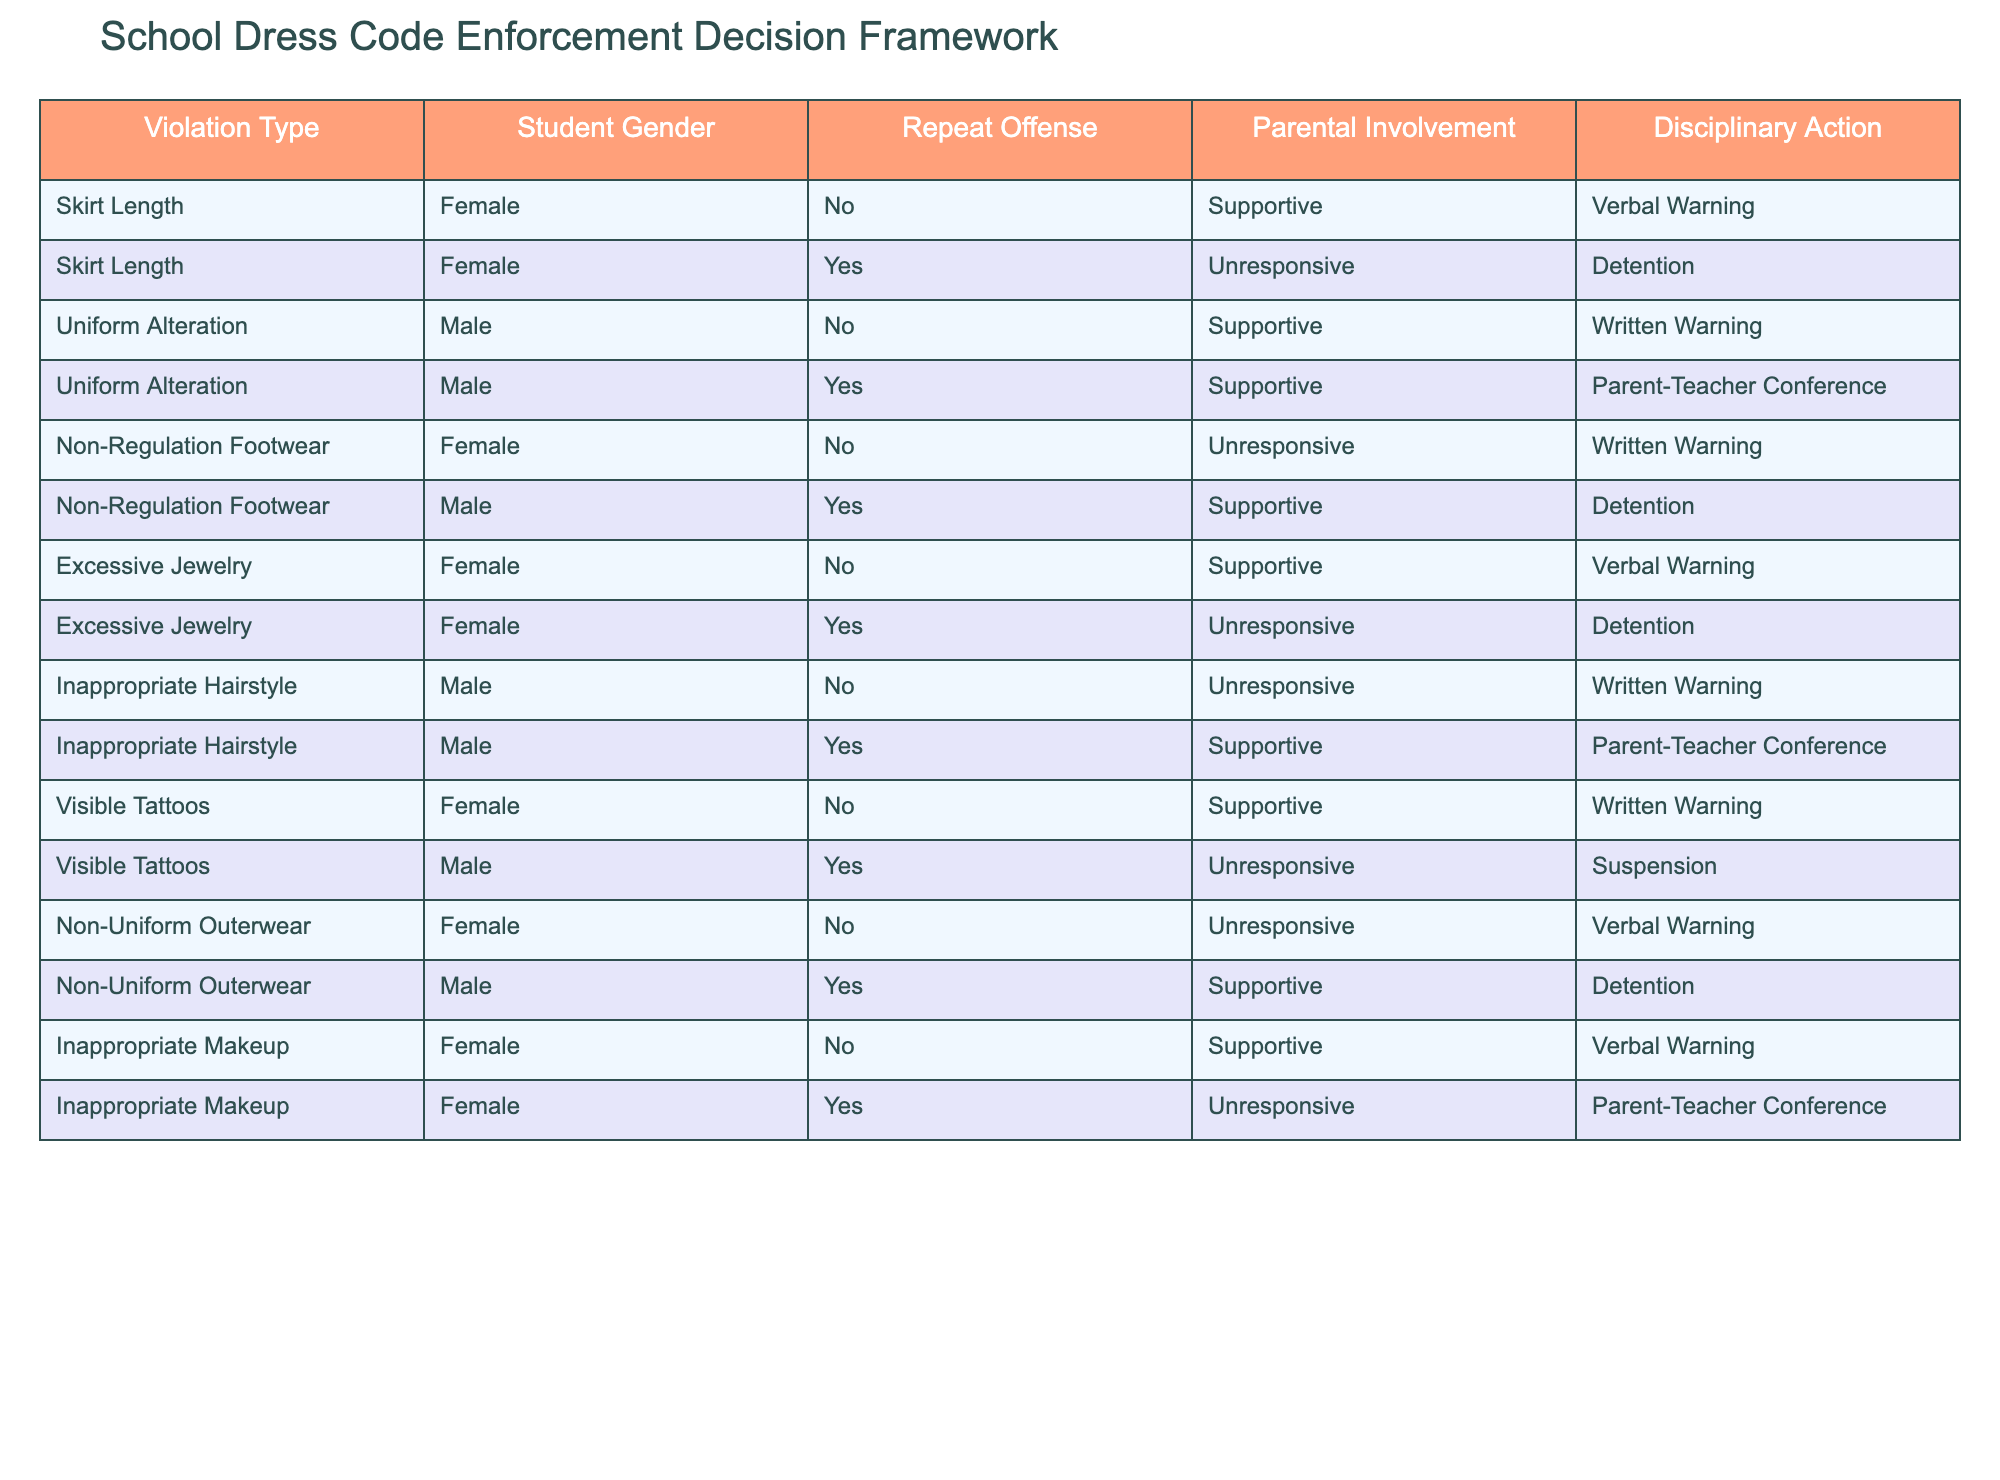What disciplinary action is given for a female student with non-regulation footwear who has parental involvement? The table indicates that for non-regulation footwear, if the female student has parental involvement, she is given a written warning since the entry for that scenario states "Unresponsive" as a condition, leading to "Written Warning."
Answer: Written Warning How many types of disciplinary actions are taken for male students with repeat offenses? By examining the table, the actions for male repeat offenders include a parent-teacher conference and detention. Therefore, there are 2 unique actions listed for male students with repeat offenses based on the table.
Answer: 2 Is there any action taken for a female student with excessive jewelry if her parents are unresponsive? The table shows that for excessive jewelry, if the female student is a repeat offender and has unresponsive parental involvement, the action taken is detention. Thus, yes, action is taken in that scenario.
Answer: Yes What is the most common disciplinary action for first-time female offenders across all violation types? By looking at the data for first-time female offenders, the most common disciplinary action is the verbal warning. This can be verified by counting the entries: verbal warnings appear for skirt length, excessive jewelry, inappropriate hairstyle, and inappropriate makeup. There are 4 verbal warnings in total, which is more than any other action for female offenders.
Answer: Verbal Warning For male students, what is the disciplinary action for uniform alteration if the parents are supportive? According to the table, if a male student alters his uniform and has supportive parents, the disciplinary action taken is a parent-teacher conference. This information is clear from the specific entry listed under uniform alteration with supportive parental involvement.
Answer: Parent-Teacher Conference What is the percentage of violations that lead to detention for students with unresponsive parental involvement? To calculate this percentage, we first identify the total number of violations with unresponsive parental involvement. From the table, there are 3 cases leading to detention (Females - excessive jewelry, males - non-regulation footwear, and males - visible tattoos), out of 6 total violations involving unresponsive parents. Thus, the percentage is calculated as (3/6) * 100 = 50%.
Answer: 50% How many instances of visible tattoos are addressed in the table and what is the corresponding disciplinary action? The table mentions visible tattoos for both genders: a female student with no parental support receives a written warning, while a male student receiving unresponsive parental involvement gets suspended. This totals to 2 instances related to visible tattoos with their respective actions.
Answer: 2 instances In which violation type does a male student receive a written warning and not detention? According to the table, the violation type for which a male student does receive a written warning is inappropriate hairstyle, particularly when it's a first-time offense with unresponsive parent involvement. This is validated by finding the specific entry in the table regarding this scenario.
Answer: Inappropriate Hairstyle 